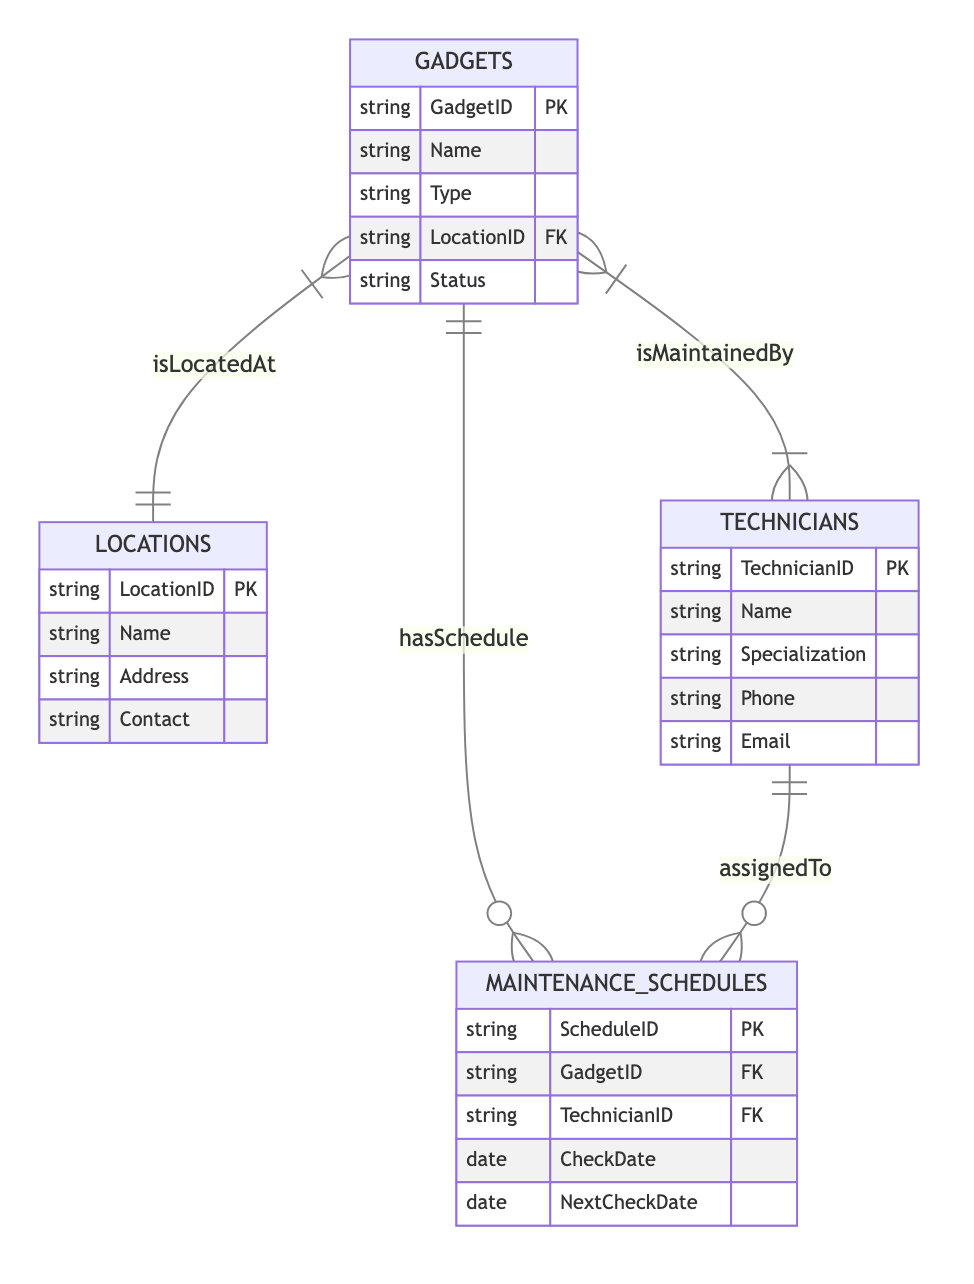What is the primary key of the Gadgets entity? The primary key for the Gadgets entity, as specified in the diagram, is GadgetID. It uniquely identifies each gadget in the inventory.
Answer: GadgetID How many entities are present in the diagram? The diagram contains four entities: Gadgets, Locations, Technicians, and MaintenanceSchedules. This counts to a total of four distinct entities represented.
Answer: 4 What relationship connects Gadgets and Locations? The relationship that connects Gadgets and Locations is labeled as "isLocatedAt." This indicates that each gadget is assigned to a specific location.
Answer: isLocatedAt How many relationships are associated with the Technicians entity? The Technicians entity is involved in two relationships: isMaintainedBy (with Gadgets) and assignedTo (with MaintenanceSchedules), making it a total of two relationships involving Technicians.
Answer: 2 What type of relationship is between Gadgets and MaintenanceSchedules? The relationship between Gadgets and MaintenanceSchedules is defined as "hasSchedule," which indicates a one-to-many association, meaning one gadget can have multiple maintenance schedules.
Answer: hasSchedule Which entity contains the attribute "Specialization"? The attribute "Specialization" is found within the Technicians entity. This attribute provides information about the specific area of expertise for each technician.
Answer: Technicians How many attributes does the Locations entity have? The Locations entity encompasses four attributes: LocationID, Name, Address, and Contact. Therefore, it has a total of four attributes.
Answer: 4 What is the cardinality of the relationship between Gadgets and Technicians? The relationship between Gadgets and Technicians is classified as many-to-many. This implies that multiple technicians can maintain multiple gadgets.
Answer: many-to-many Which entity is responsible for storing contacts for locations? The entity that stores contact information for locations is the Locations entity, which includes an attribute specifically for contact details.
Answer: Locations 